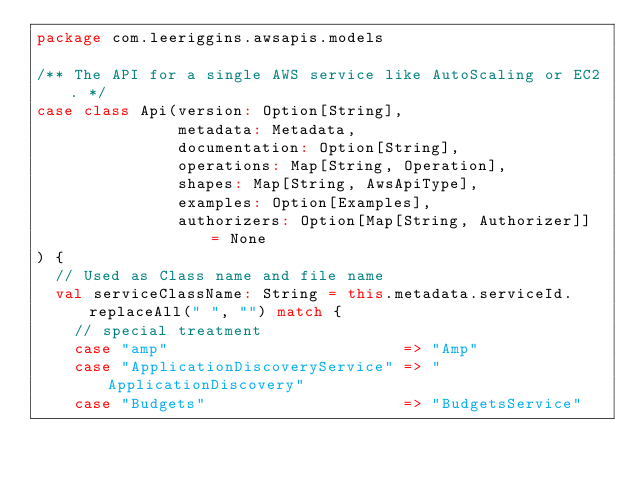Convert code to text. <code><loc_0><loc_0><loc_500><loc_500><_Scala_>package com.leeriggins.awsapis.models

/** The API for a single AWS service like AutoScaling or EC2. */
case class Api(version: Option[String],
               metadata: Metadata,
               documentation: Option[String],
               operations: Map[String, Operation],
               shapes: Map[String, AwsApiType],
               examples: Option[Examples],
               authorizers: Option[Map[String, Authorizer]] = None
) {
  // Used as Class name and file name
  val serviceClassName: String = this.metadata.serviceId.replaceAll(" ", "") match {
    // special treatment
    case "amp"                         => "Amp"
    case "ApplicationDiscoveryService" => "ApplicationDiscovery"
    case "Budgets"                     => "BudgetsService"</code> 